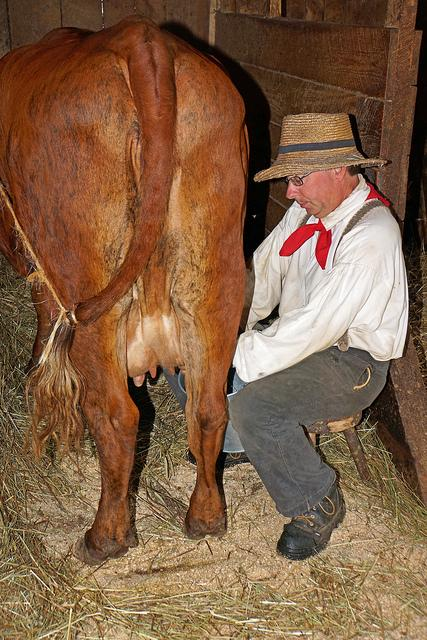What activity is this man involved in?

Choices:
A) milking
B) sleeping
C) examination
D) sales milking 